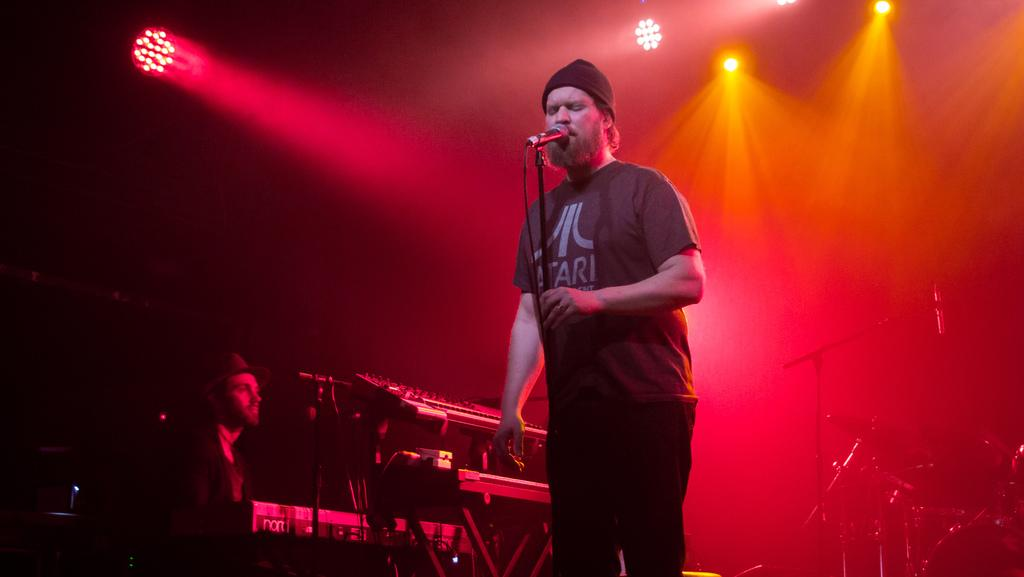What is the man in the image doing? The man is singing on the microphone. Can you describe the person present in the image? There is a person present, but their specific role or activity is not mentioned in the facts. What else can be seen in the image besides the man singing? Musical instruments are visible in the image. What can be seen in the background of the image? There are lights in the background. What type of bells can be heard ringing in the image? There is no mention of bells or any sound in the image, so it is not possible to determine if any bells are ringing. 